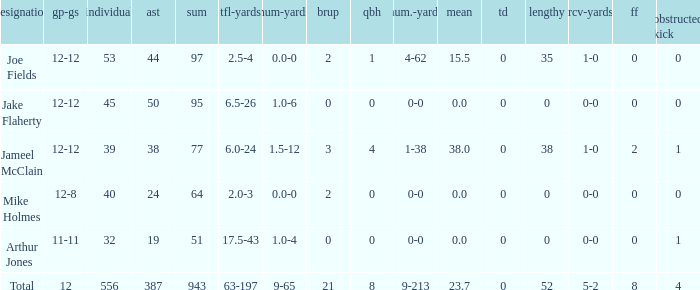How many tackle assists for the player who averages 23.7? 387.0. I'm looking to parse the entire table for insights. Could you assist me with that? {'header': ['designation', 'gp-gs', 'individual', 'ast', 'sum', 'tfl-yards', 'num-yards', 'brup', 'qbh', 'num.-yards', 'mean', 'td', 'lengthy', 'rcv-yards', 'ff', 'obstructed kick'], 'rows': [['Joe Fields', '12-12', '53', '44', '97', '2.5-4', '0.0-0', '2', '1', '4-62', '15.5', '0', '35', '1-0', '0', '0'], ['Jake Flaherty', '12-12', '45', '50', '95', '6.5-26', '1.0-6', '0', '0', '0-0', '0.0', '0', '0', '0-0', '0', '0'], ['Jameel McClain', '12-12', '39', '38', '77', '6.0-24', '1.5-12', '3', '4', '1-38', '38.0', '0', '38', '1-0', '2', '1'], ['Mike Holmes', '12-8', '40', '24', '64', '2.0-3', '0.0-0', '2', '0', '0-0', '0.0', '0', '0', '0-0', '0', '0'], ['Arthur Jones', '11-11', '32', '19', '51', '17.5-43', '1.0-4', '0', '0', '0-0', '0.0', '0', '0', '0-0', '0', '1'], ['Total', '12', '556', '387', '943', '63-197', '9-65', '21', '8', '9-213', '23.7', '0', '52', '5-2', '8', '4']]} 